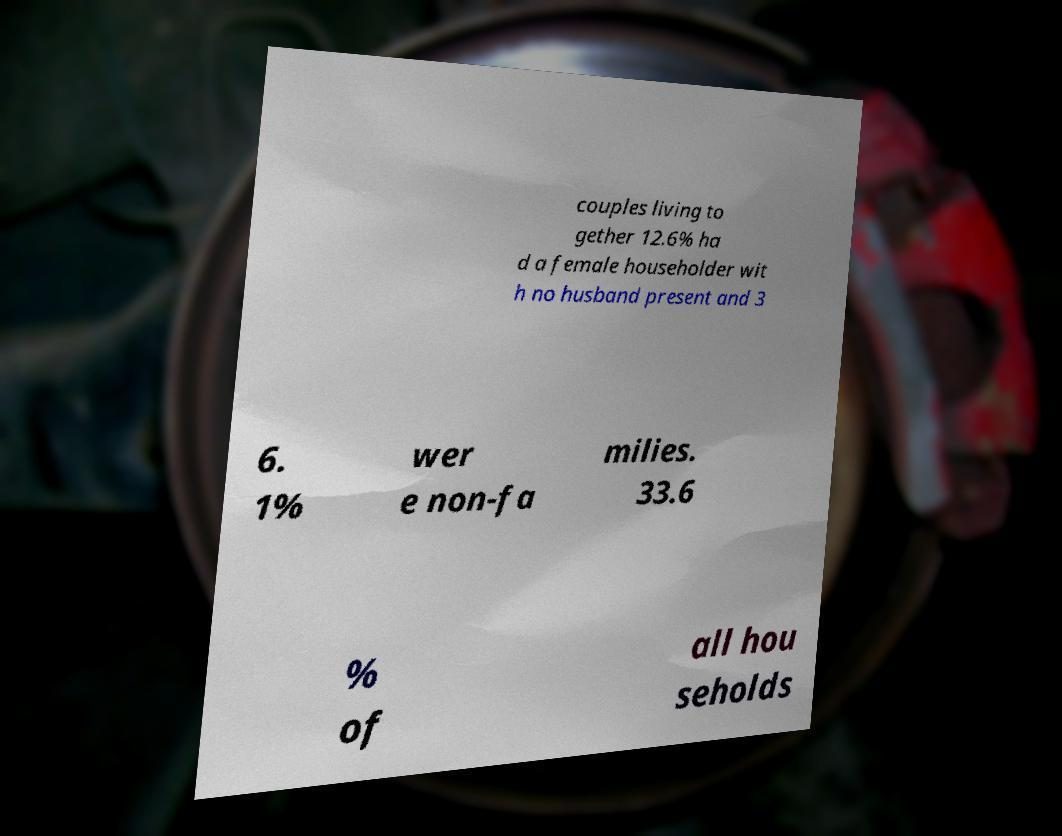I need the written content from this picture converted into text. Can you do that? couples living to gether 12.6% ha d a female householder wit h no husband present and 3 6. 1% wer e non-fa milies. 33.6 % of all hou seholds 